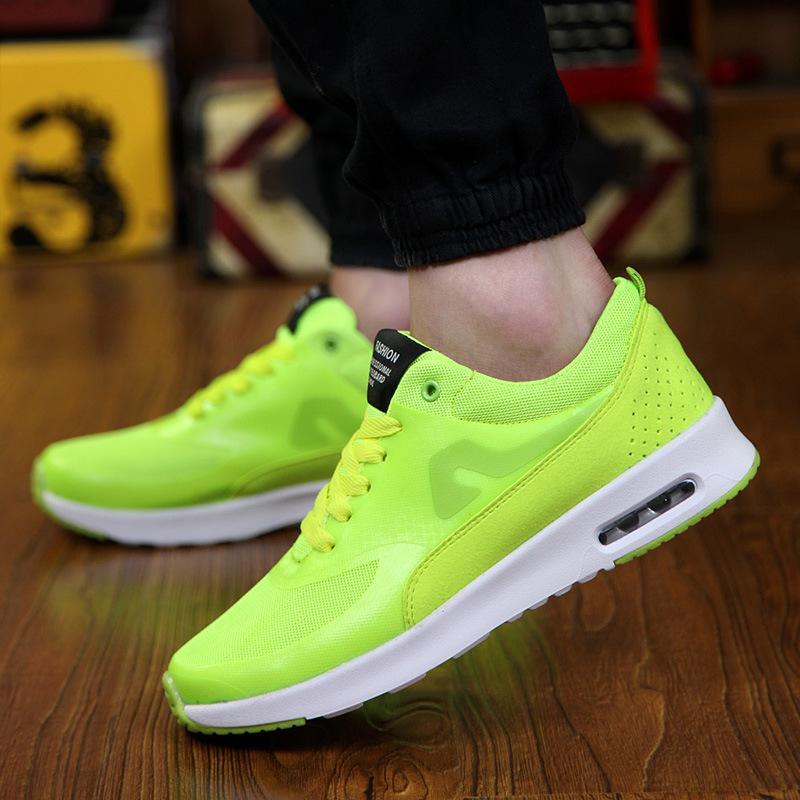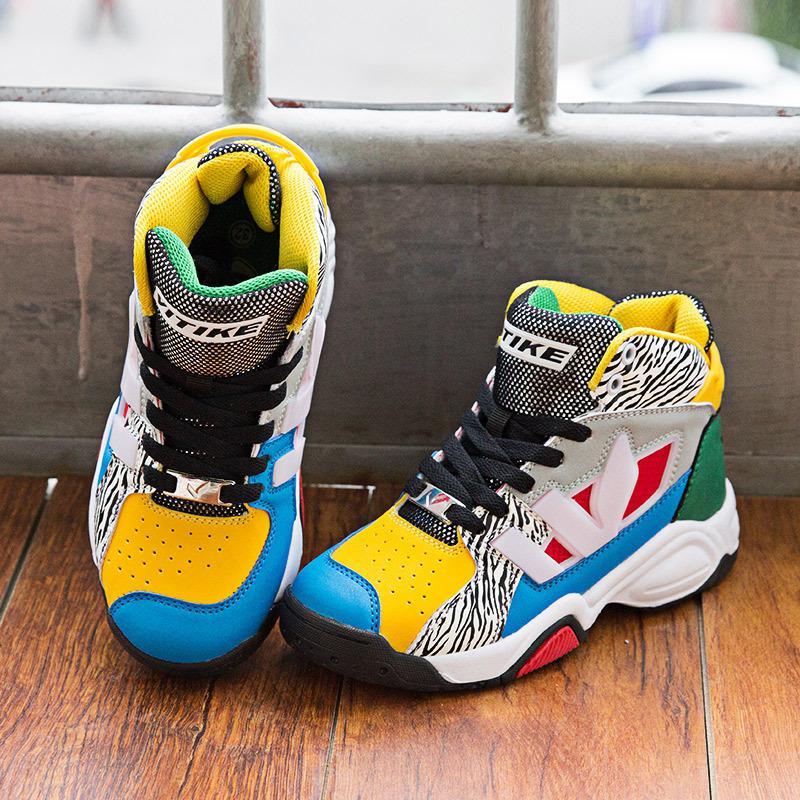The first image is the image on the left, the second image is the image on the right. For the images shown, is this caption "An image shows a pair of black sneakers posed on a shoe box." true? Answer yes or no. No. The first image is the image on the left, the second image is the image on the right. For the images displayed, is the sentence "There is a black pair of sneakers sitting on a shoe box in the image on the right." factually correct? Answer yes or no. No. 